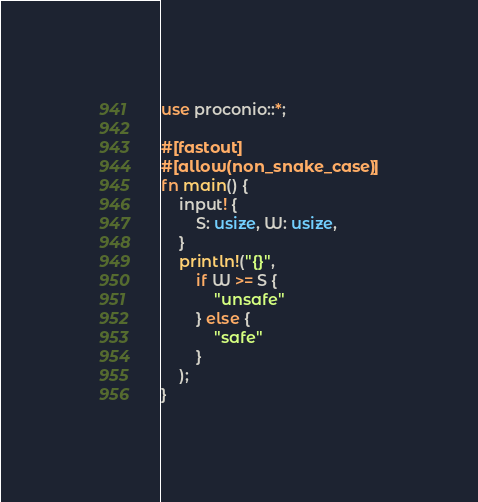<code> <loc_0><loc_0><loc_500><loc_500><_Rust_>use proconio::*;

#[fastout]
#[allow(non_snake_case)]
fn main() {
    input! {
        S: usize, W: usize,
    }
    println!("{}",
        if W >= S {
            "unsafe"
        } else {
            "safe"
        }
    );
}
</code> 